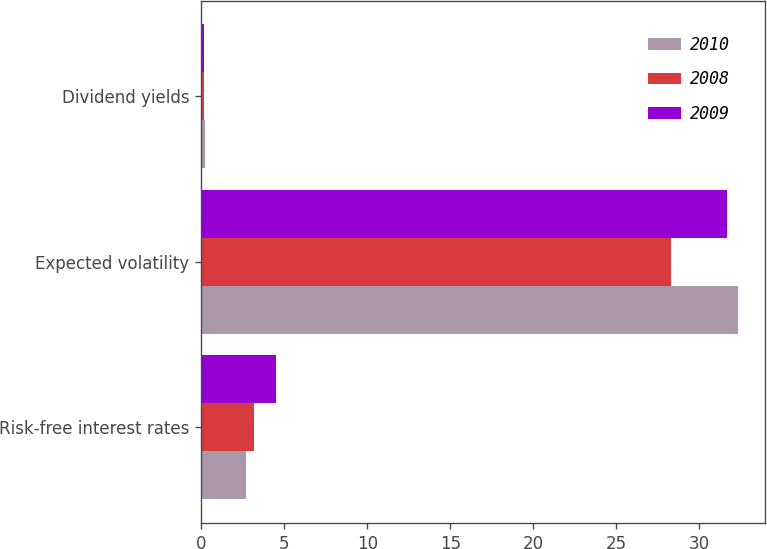<chart> <loc_0><loc_0><loc_500><loc_500><stacked_bar_chart><ecel><fcel>Risk-free interest rates<fcel>Expected volatility<fcel>Dividend yields<nl><fcel>2010<fcel>2.72<fcel>32.31<fcel>0.21<nl><fcel>2008<fcel>3.15<fcel>28.27<fcel>0.19<nl><fcel>2009<fcel>4.49<fcel>31.67<fcel>0.19<nl></chart> 